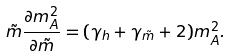Convert formula to latex. <formula><loc_0><loc_0><loc_500><loc_500>\tilde { m } \frac { \partial m _ { A } ^ { 2 } } { \partial \tilde { m } } = ( \gamma _ { h } + \gamma _ { \tilde { m } } + 2 ) m _ { A } ^ { 2 } .</formula> 